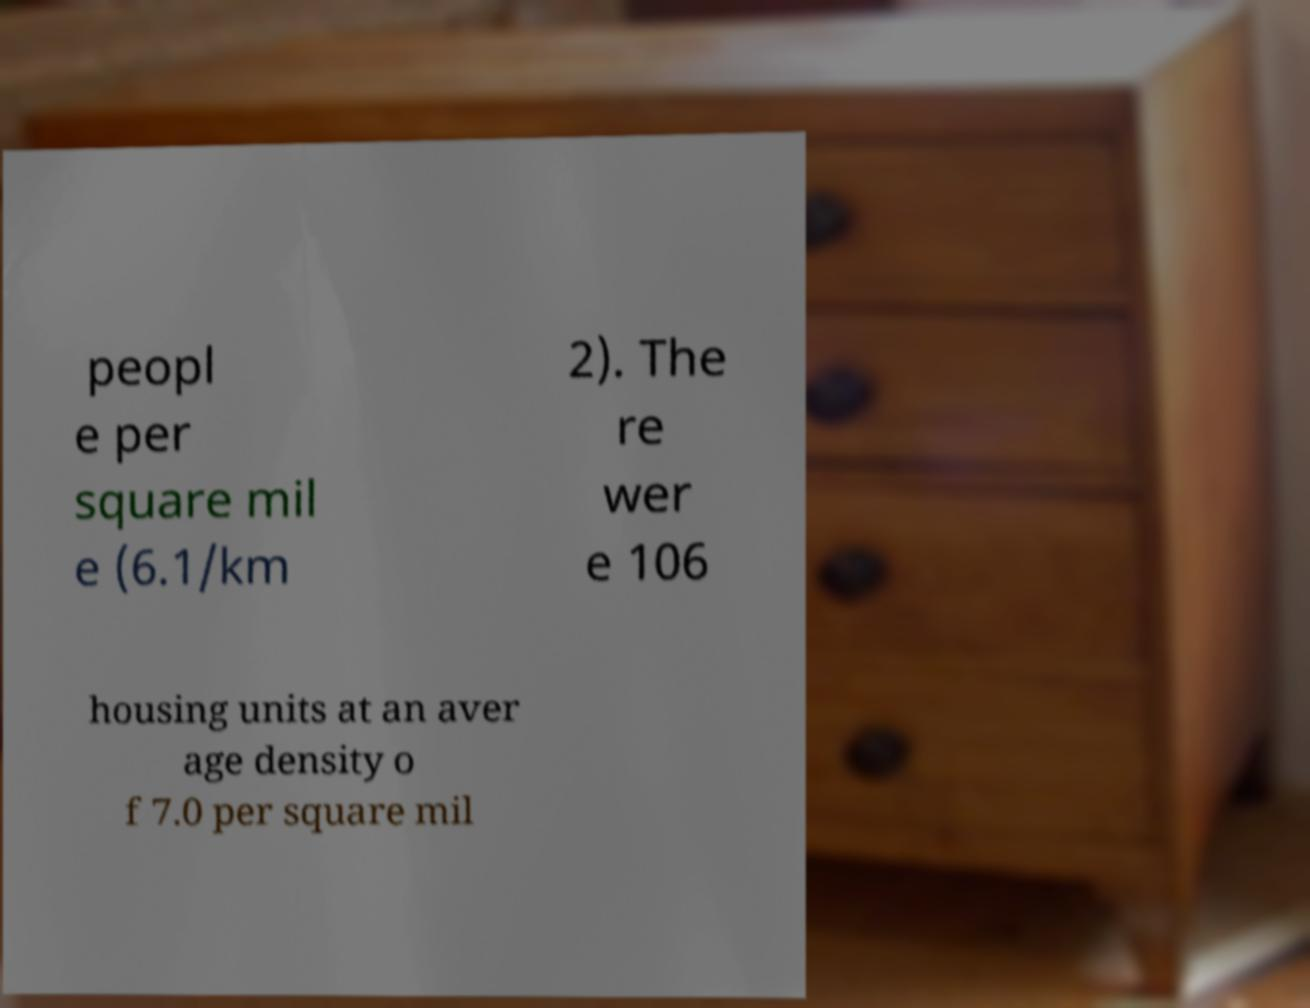For documentation purposes, I need the text within this image transcribed. Could you provide that? peopl e per square mil e (6.1/km 2). The re wer e 106 housing units at an aver age density o f 7.0 per square mil 